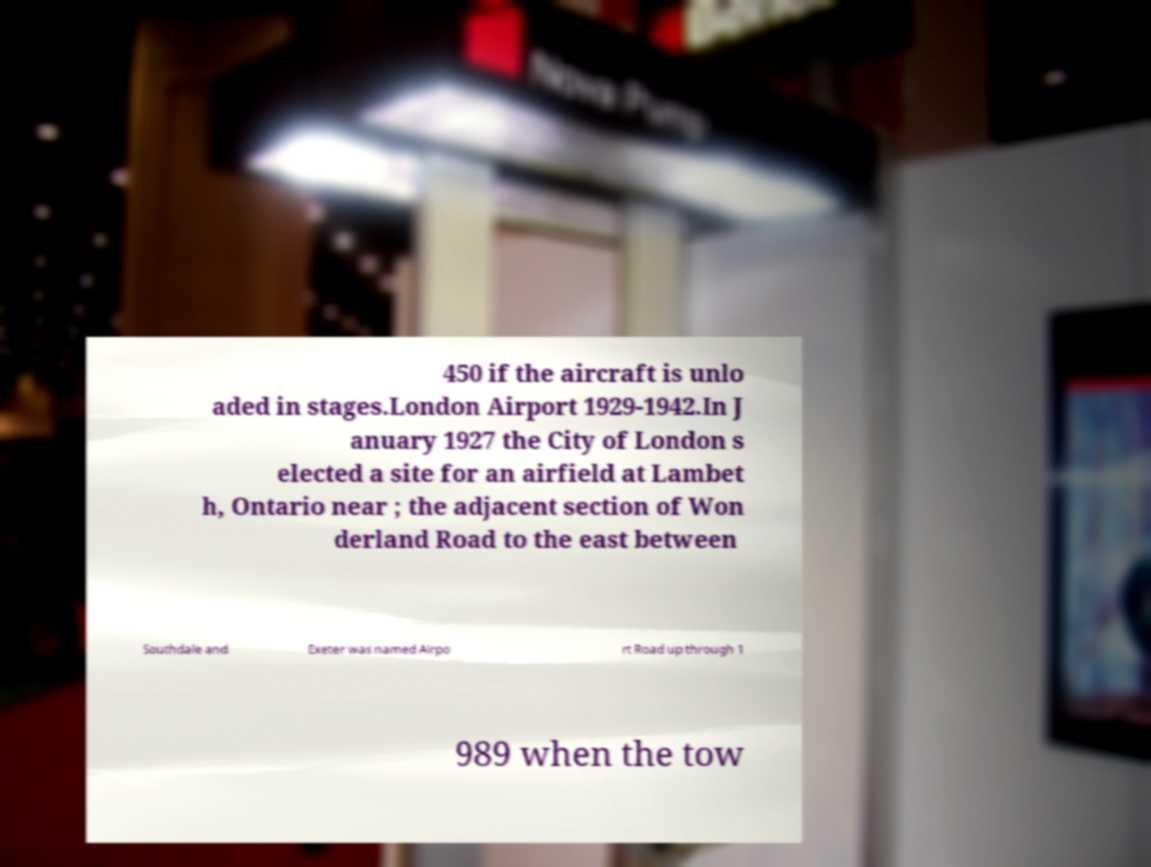Can you accurately transcribe the text from the provided image for me? 450 if the aircraft is unlo aded in stages.London Airport 1929-1942.In J anuary 1927 the City of London s elected a site for an airfield at Lambet h, Ontario near ; the adjacent section of Won derland Road to the east between Southdale and Exeter was named Airpo rt Road up through 1 989 when the tow 